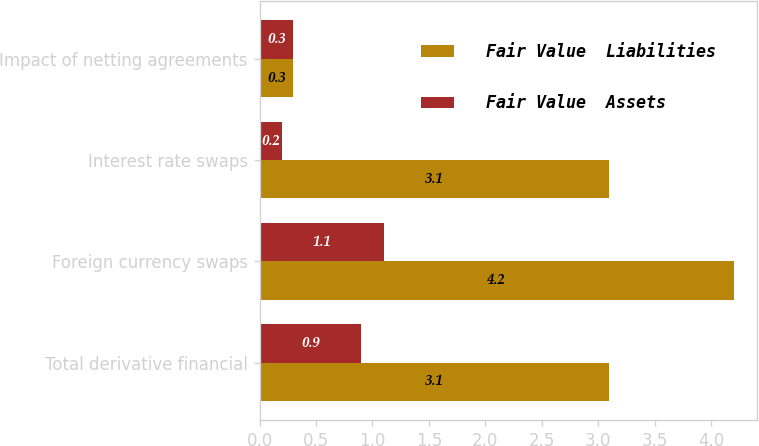Convert chart. <chart><loc_0><loc_0><loc_500><loc_500><stacked_bar_chart><ecel><fcel>Total derivative financial<fcel>Foreign currency swaps<fcel>Interest rate swaps<fcel>Impact of netting agreements<nl><fcel>Fair Value  Liabilities<fcel>3.1<fcel>4.2<fcel>3.1<fcel>0.3<nl><fcel>Fair Value  Assets<fcel>0.9<fcel>1.1<fcel>0.2<fcel>0.3<nl></chart> 